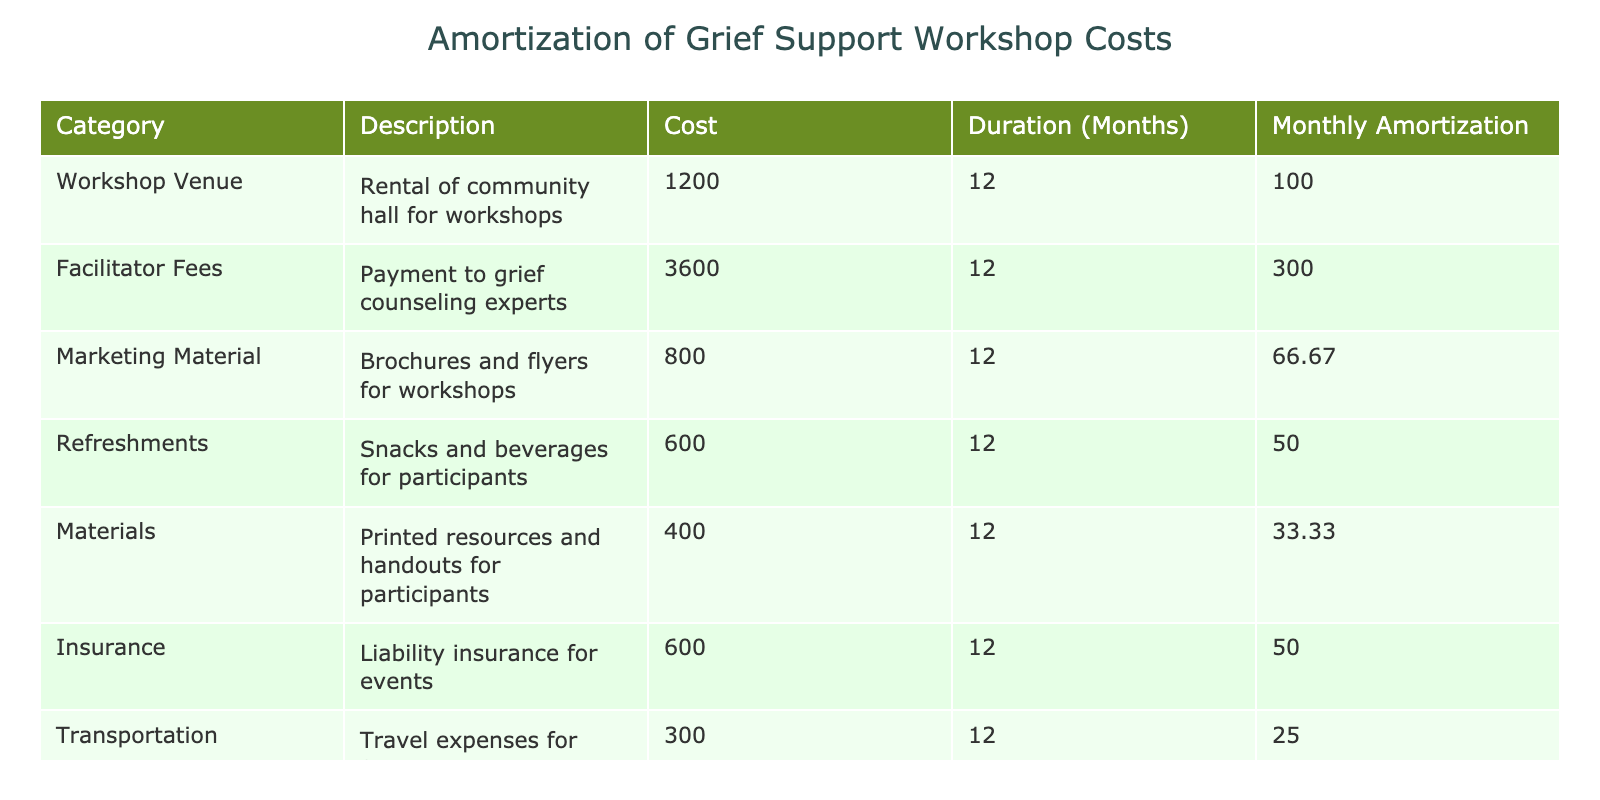What is the total cost associated with the grief support workshops? The table shows a total cost row at the bottom, which lists the "Total Costs" as 7200.
Answer: 7200 How much is allocated for facilitator fees each month? The table lists "Facilitator Fees" with a monthly amortization of 300 in the corresponding column.
Answer: 300 Which cost category has the lowest monthly amortization? By looking through the "Monthly Amortization" column, we see that "Materials" has an amortization of 33.33, which is the lowest among all categories.
Answer: 33.33 How much do transportation expenses contribute to the total monthly amortization? Transportation has a monthly amortization of 25. To find the total, we can see that it is subtracted from the overall 625 monthly amortization. Its contribution is accounted for the total.
Answer: 25 Is the cost of marketing material greater than the cost of refreshments? The "Marketing Material" is listed at 800 and "Refreshments" at 600; since 800 is greater than 600, we can confirm the statement is true.
Answer: Yes What is the combined monthly amortization of workshop venue rental and liability insurance? The monthly amortization for the workshop venue is 100 and for insurance is 50. Adding these gives a total of 150 (100 + 50).
Answer: 150 If we exclude facilitator fees from total costs, what would be the new monthly amortization? The total monthly amortization is 625, and facilitator fees are 300. If we subtract the facilitator’s fees, the new monthly amortization is 625 - 300 = 325.
Answer: 325 What percentage of the total amortization do refreshments account for? The monthly amortization for refreshments is 50, and total amortization is 625. Calculating the percentage, (50 / 625) * 100 = 8.00%.
Answer: 8.00% How much more is spent on marketing material compared to materials for participants? Marketing material costs 800, while materials cost 400. Subtracting the two gives 800 - 400 = 400, showing that marketing material costs 400 more.
Answer: 400 